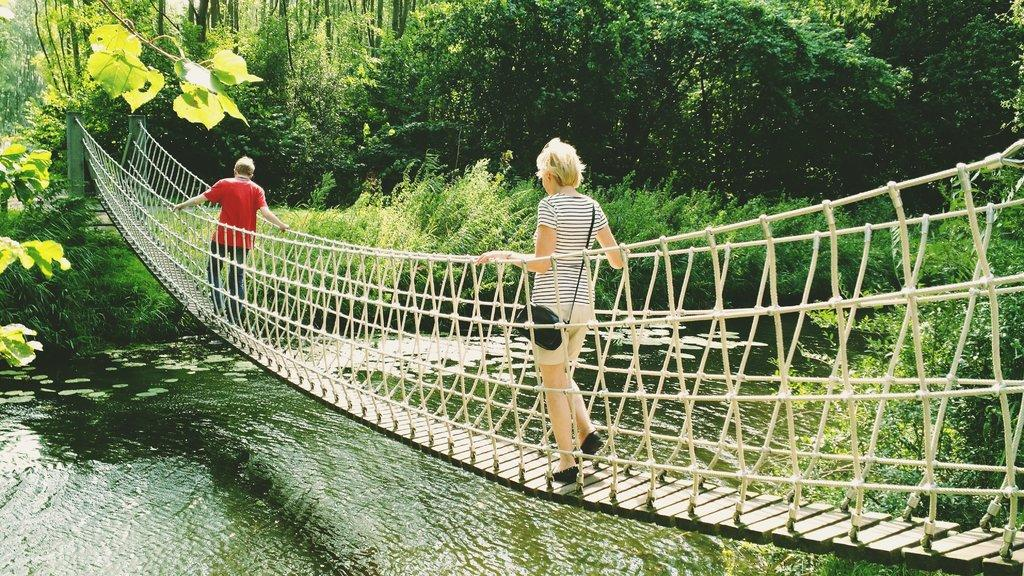Who is present in the image? There is a man and a woman in the image. What are the man and woman doing in the image? Both the man and woman are walking on a rope bridge. What can be seen below the rope bridge in the image? There is water visible at the bottom of the image. What type of vegetation is visible in the background of the image? There are trees and plants in the background of the image. What type of plastic material is being used to support the rope bridge in the image? There is no plastic material visible in the image; the rope bridge appears to be made of rope and wood. How does the cork float on the water in the image? There is no cork present in the image; it only features a man, a woman, a rope bridge, water, trees, and plants. 